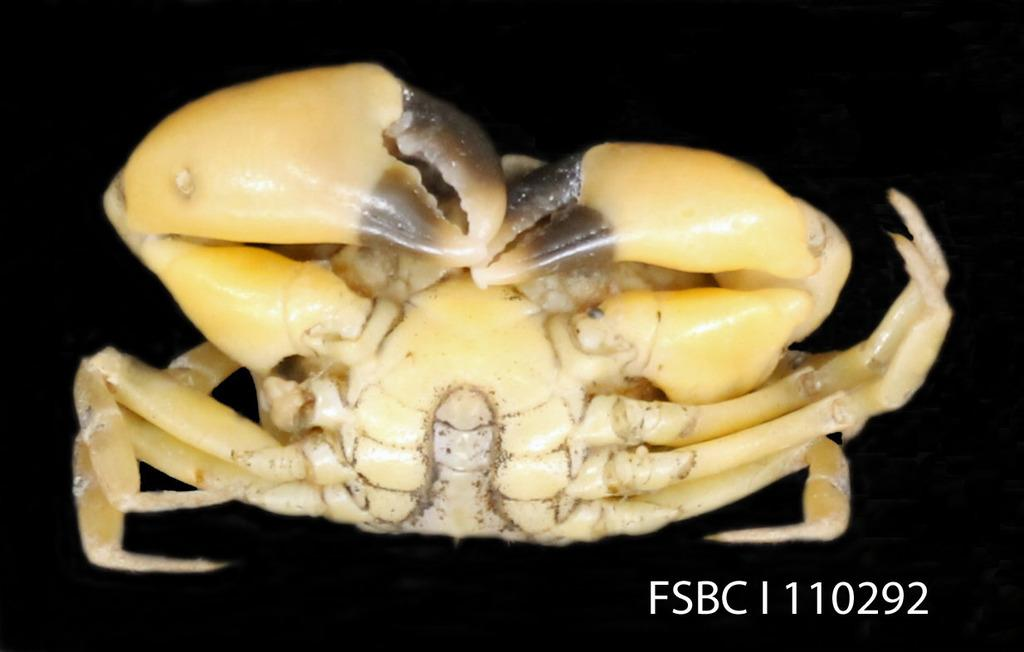What type of animal is in the image? There is a crab in the image. What color is the crab? The crab is brown in color. What type of door can be seen in the image? There is no door present in the image; it features a brown crab. What level of expertise does the crab have in the image? The crab is not a person, so it does not have a level of expertise. 